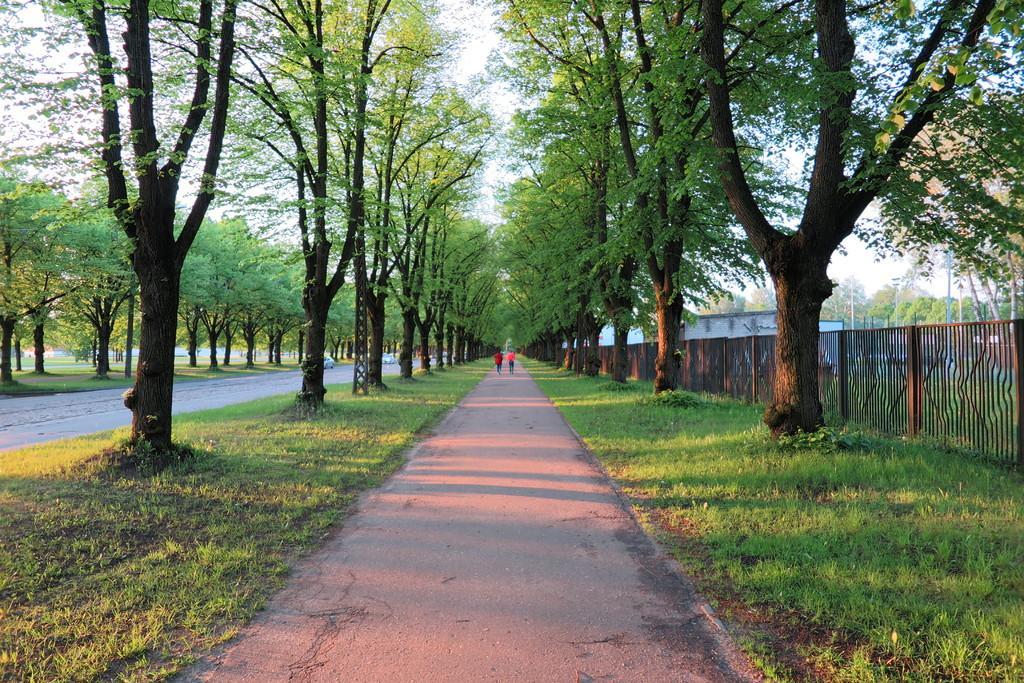How would you summarize this image in a sentence or two? This image is taken outdoors. At the bottom of the image there is a road and there is a ground with grass on it. On the right side of the image there is a wooden fence and there is a house. There are a few trees. In the middle of the image two people are walking on the road. There are many trees on the ground. 